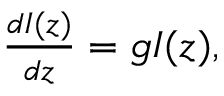<formula> <loc_0><loc_0><loc_500><loc_500>\begin{array} { r } { \frac { d I ( z ) } { d z } = g I ( z ) , } \end{array}</formula> 